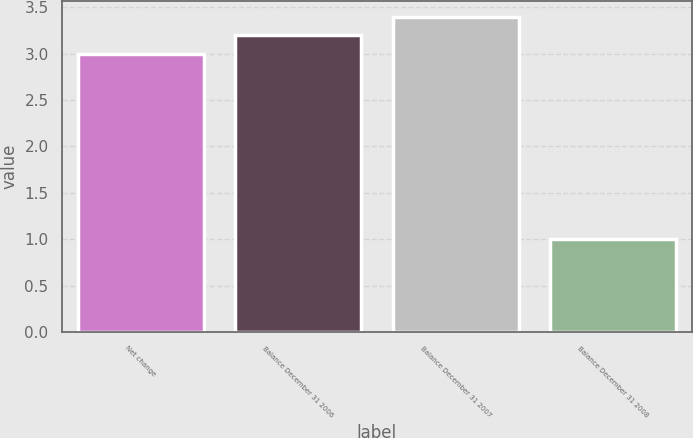Convert chart. <chart><loc_0><loc_0><loc_500><loc_500><bar_chart><fcel>Net change<fcel>Balance December 31 2006<fcel>Balance December 31 2007<fcel>Balance December 31 2008<nl><fcel>3<fcel>3.2<fcel>3.4<fcel>1<nl></chart> 